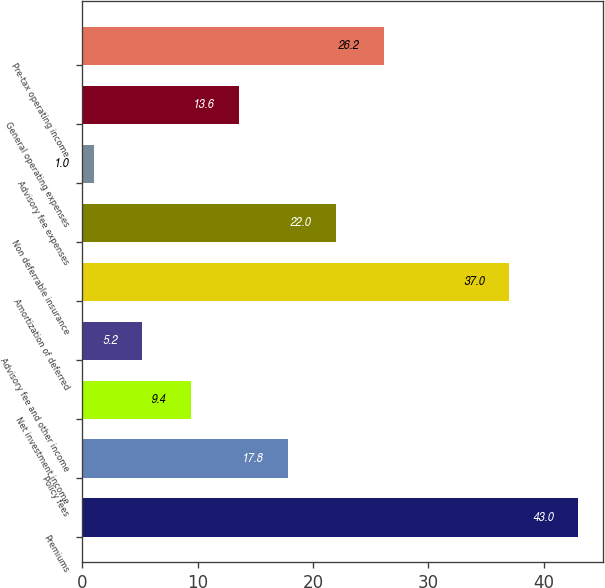Convert chart to OTSL. <chart><loc_0><loc_0><loc_500><loc_500><bar_chart><fcel>Premiums<fcel>Policy fees<fcel>Net investment income<fcel>Advisory fee and other income<fcel>Amortization of deferred<fcel>Non deferrable insurance<fcel>Advisory fee expenses<fcel>General operating expenses<fcel>Pre-tax operating income<nl><fcel>43<fcel>17.8<fcel>9.4<fcel>5.2<fcel>37<fcel>22<fcel>1<fcel>13.6<fcel>26.2<nl></chart> 